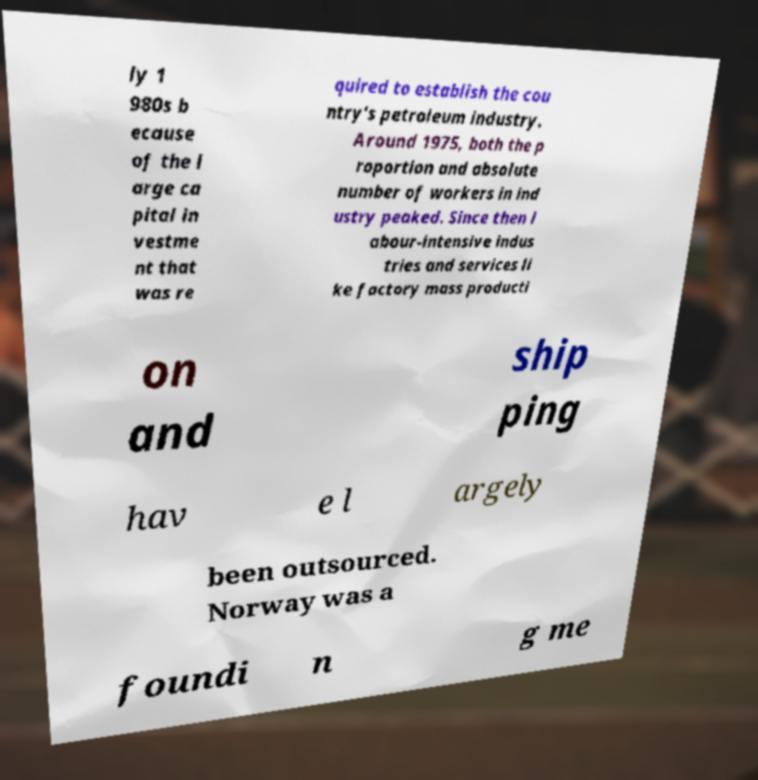Can you accurately transcribe the text from the provided image for me? ly 1 980s b ecause of the l arge ca pital in vestme nt that was re quired to establish the cou ntry's petroleum industry. Around 1975, both the p roportion and absolute number of workers in ind ustry peaked. Since then l abour-intensive indus tries and services li ke factory mass producti on and ship ping hav e l argely been outsourced. Norway was a foundi n g me 